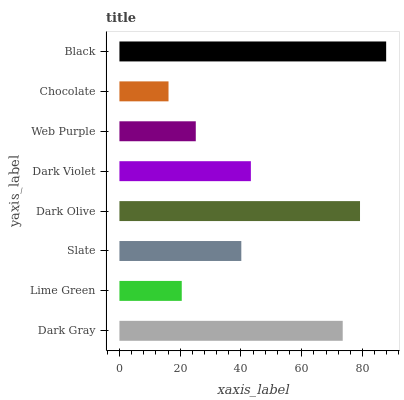Is Chocolate the minimum?
Answer yes or no. Yes. Is Black the maximum?
Answer yes or no. Yes. Is Lime Green the minimum?
Answer yes or no. No. Is Lime Green the maximum?
Answer yes or no. No. Is Dark Gray greater than Lime Green?
Answer yes or no. Yes. Is Lime Green less than Dark Gray?
Answer yes or no. Yes. Is Lime Green greater than Dark Gray?
Answer yes or no. No. Is Dark Gray less than Lime Green?
Answer yes or no. No. Is Dark Violet the high median?
Answer yes or no. Yes. Is Slate the low median?
Answer yes or no. Yes. Is Chocolate the high median?
Answer yes or no. No. Is Dark Violet the low median?
Answer yes or no. No. 